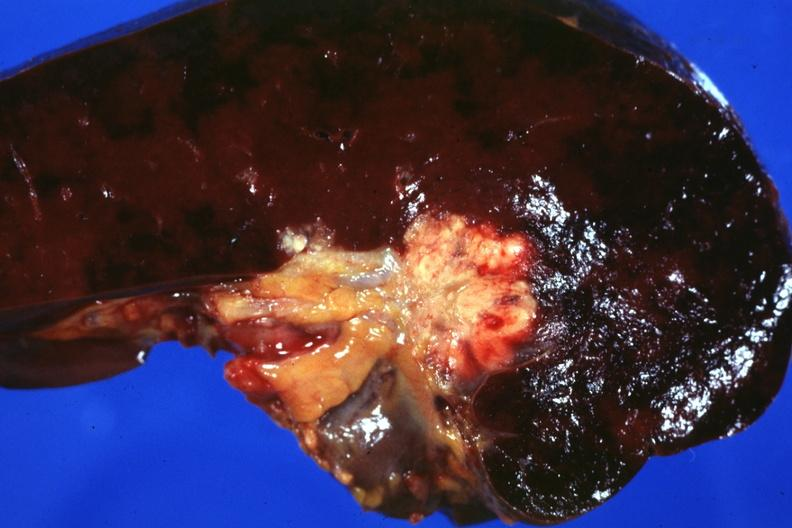does this image show section of spleen through hilum show tumor mass in hilum slide and large metastatic nodules in spleen?
Answer the question using a single word or phrase. Yes 